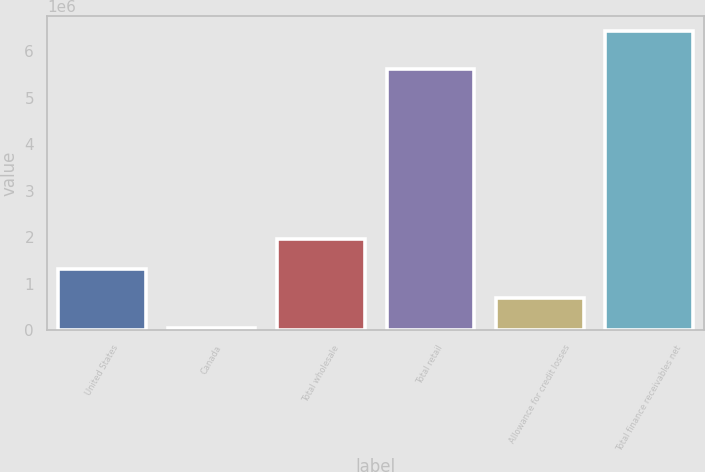<chart> <loc_0><loc_0><loc_500><loc_500><bar_chart><fcel>United States<fcel>Canada<fcel>Total wholesale<fcel>Total retail<fcel>Allowance for credit losses<fcel>Total finance receivables net<nl><fcel>1.32573e+06<fcel>48941<fcel>1.96412e+06<fcel>5.60792e+06<fcel>687335<fcel>6.43288e+06<nl></chart> 